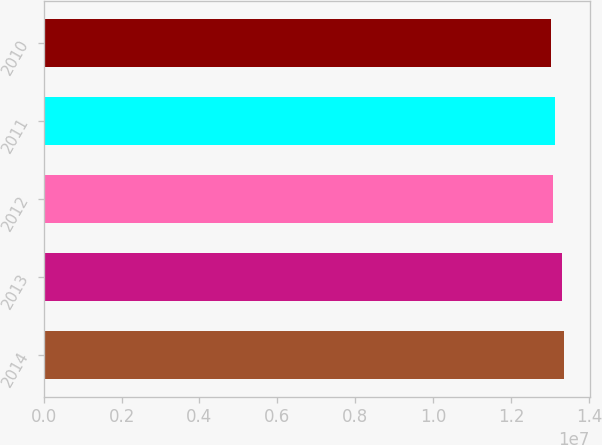<chart> <loc_0><loc_0><loc_500><loc_500><bar_chart><fcel>2014<fcel>2013<fcel>2012<fcel>2011<fcel>2010<nl><fcel>1.3346e+07<fcel>1.3302e+07<fcel>1.308e+07<fcel>1.3126e+07<fcel>1.3028e+07<nl></chart> 